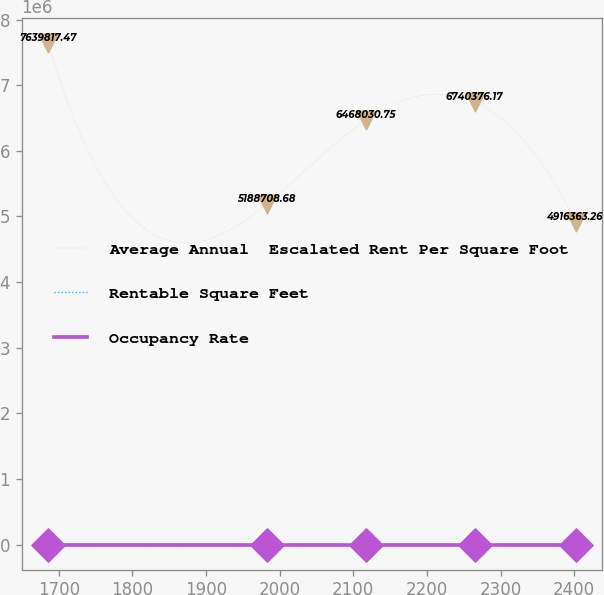<chart> <loc_0><loc_0><loc_500><loc_500><line_chart><ecel><fcel>Average Annual  Escalated Rent Per Square Foot<fcel>Rentable Square Feet<fcel>Occupancy Rate<nl><fcel>1685.39<fcel>7.63982e+06<fcel>107.08<fcel>25.06<nl><fcel>1982.69<fcel>5.18871e+06<fcel>94.48<fcel>27.92<nl><fcel>2116.67<fcel>6.46803e+06<fcel>98.6<fcel>24.13<nl><fcel>2265.03<fcel>6.74038e+06<fcel>91.96<fcel>21.09<nl><fcel>2402.13<fcel>4.91636e+06<fcel>81.86<fcel>19.69<nl></chart> 